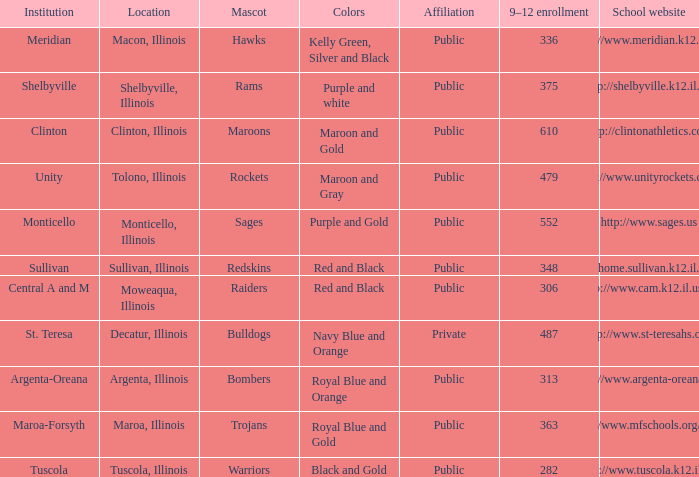What's the website of the school in Macon, Illinois? Http://www.meridian.k12.il.us/. 